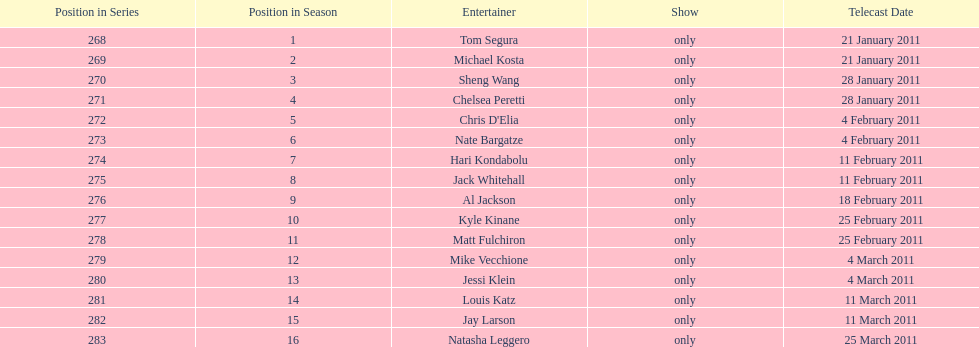What was hari's last name? Kondabolu. Can you parse all the data within this table? {'header': ['Position in Series', 'Position in Season', 'Entertainer', 'Show', 'Telecast Date'], 'rows': [['268', '1', 'Tom Segura', 'only', '21 January 2011'], ['269', '2', 'Michael Kosta', 'only', '21 January 2011'], ['270', '3', 'Sheng Wang', 'only', '28 January 2011'], ['271', '4', 'Chelsea Peretti', 'only', '28 January 2011'], ['272', '5', "Chris D'Elia", 'only', '4 February 2011'], ['273', '6', 'Nate Bargatze', 'only', '4 February 2011'], ['274', '7', 'Hari Kondabolu', 'only', '11 February 2011'], ['275', '8', 'Jack Whitehall', 'only', '11 February 2011'], ['276', '9', 'Al Jackson', 'only', '18 February 2011'], ['277', '10', 'Kyle Kinane', 'only', '25 February 2011'], ['278', '11', 'Matt Fulchiron', 'only', '25 February 2011'], ['279', '12', 'Mike Vecchione', 'only', '4 March 2011'], ['280', '13', 'Jessi Klein', 'only', '4 March 2011'], ['281', '14', 'Louis Katz', 'only', '11 March 2011'], ['282', '15', 'Jay Larson', 'only', '11 March 2011'], ['283', '16', 'Natasha Leggero', 'only', '25 March 2011']]} 